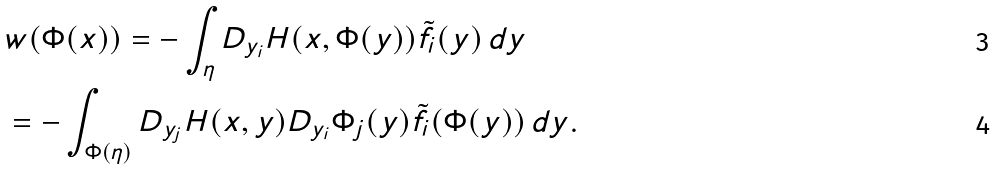<formula> <loc_0><loc_0><loc_500><loc_500>& w ( \Phi ( x ) ) = - \int _ { \eta } D _ { y _ { i } } H ( x , \Phi ( y ) ) \tilde { f } _ { i } ( y ) \, d y \\ & = - \int _ { \Phi ( \eta ) } D _ { y _ { j } } H ( x , y ) D _ { y _ { i } } \Phi _ { j } ( y ) \tilde { f } _ { i } ( \Phi ( y ) ) \, d y .</formula> 